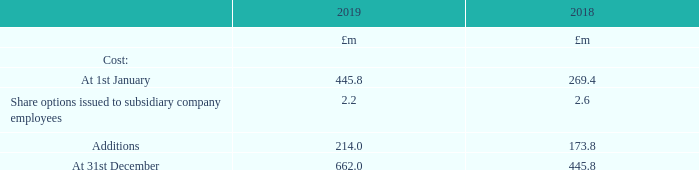2 Investments in subsidiaries
Investments are stated at cost less provisions for any impairment in value.
Additions in the year relate to investments in Gestra Holdings Limited £1.6m and Spirax Sarco America Investments Limited £212.4m. Spirax Sarco America Investments Limited was incorporated on 24th October 2018 with the purpose of holding Group US$ investments and loans. Gestra Holdings Limited was incorporated on 9th October 2018 with the purpose of holding other Gestra Companies.
Details relating to subsidiary undertakings are given on pages 207 to 211. Except where stated all classes of shares were 100% owned by the Group at 31st December 2019. The country of incorporation of the principal Group companies is the same as the country of operation with the exception of companies operating in the United Kingdom which are incorporated in Great Britain. All operate in steam, electrical thermal energy solutions, fluid path technologies or peristaltic pumping markets except those companies identified as a holding company on pages 207 to 211.
What is the country of incorporation of the principal Group companies? The same as the country of operation with the exception of companies operating in the united kingdom which are incorporated in great britain. What is the cost of investment at the end of 2019?
Answer scale should be: million. 662.0. What made up the Additions in the year of 2019? Investments in gestra holdings limited £1.6m, spirax sarco america investments limited £212.4m. In which year was the Share options issued to subsidiary company employees larger? 2.6>2.2
Answer: 2018. What was the change in the cost at 31st December in 2019 from 2018?
Answer scale should be: million. 662.0-445.8
Answer: 216.2. What was the percentage change in the cost at 31st December in 2019 from 2018?
Answer scale should be: percent. (662.0-445.8)/445.8
Answer: 48.5. 